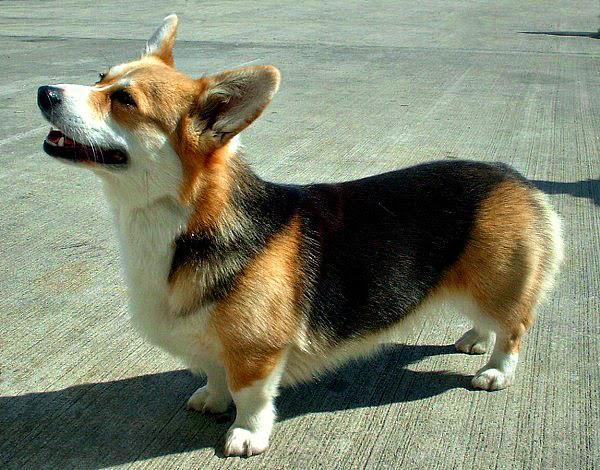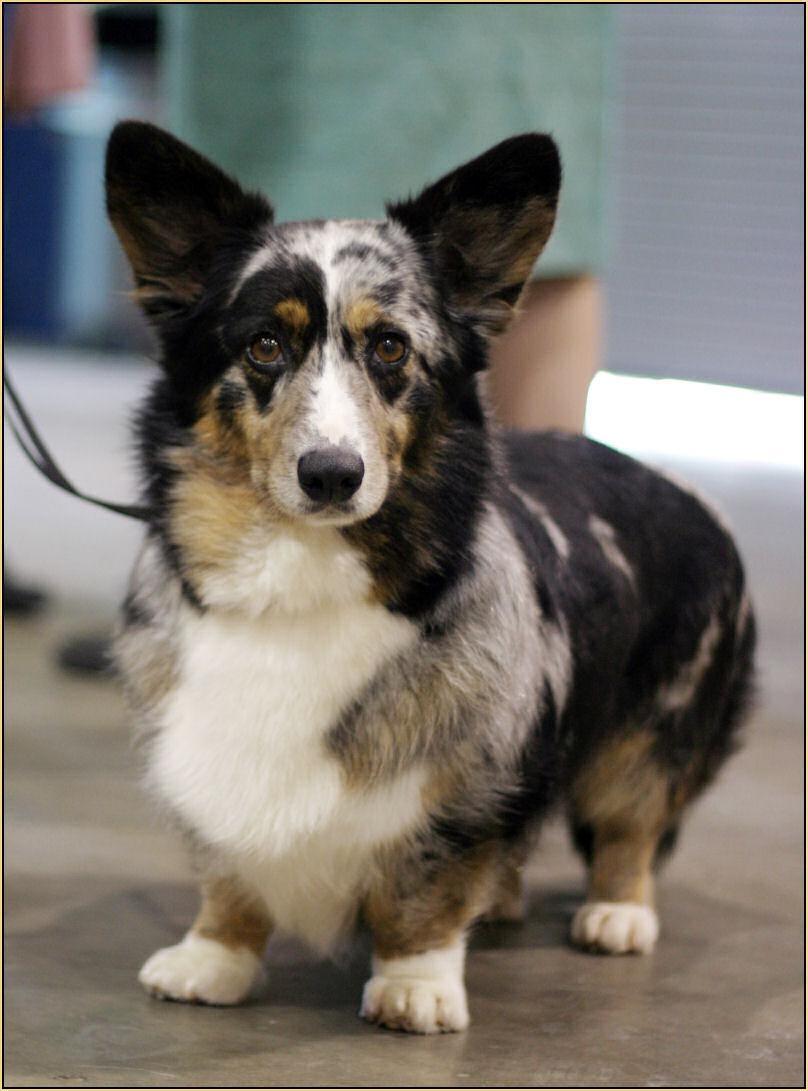The first image is the image on the left, the second image is the image on the right. Considering the images on both sides, is "The right image contains at least two dogs." valid? Answer yes or no. No. The first image is the image on the left, the second image is the image on the right. Considering the images on both sides, is "Less than four corgis are in the pair." valid? Answer yes or no. Yes. 